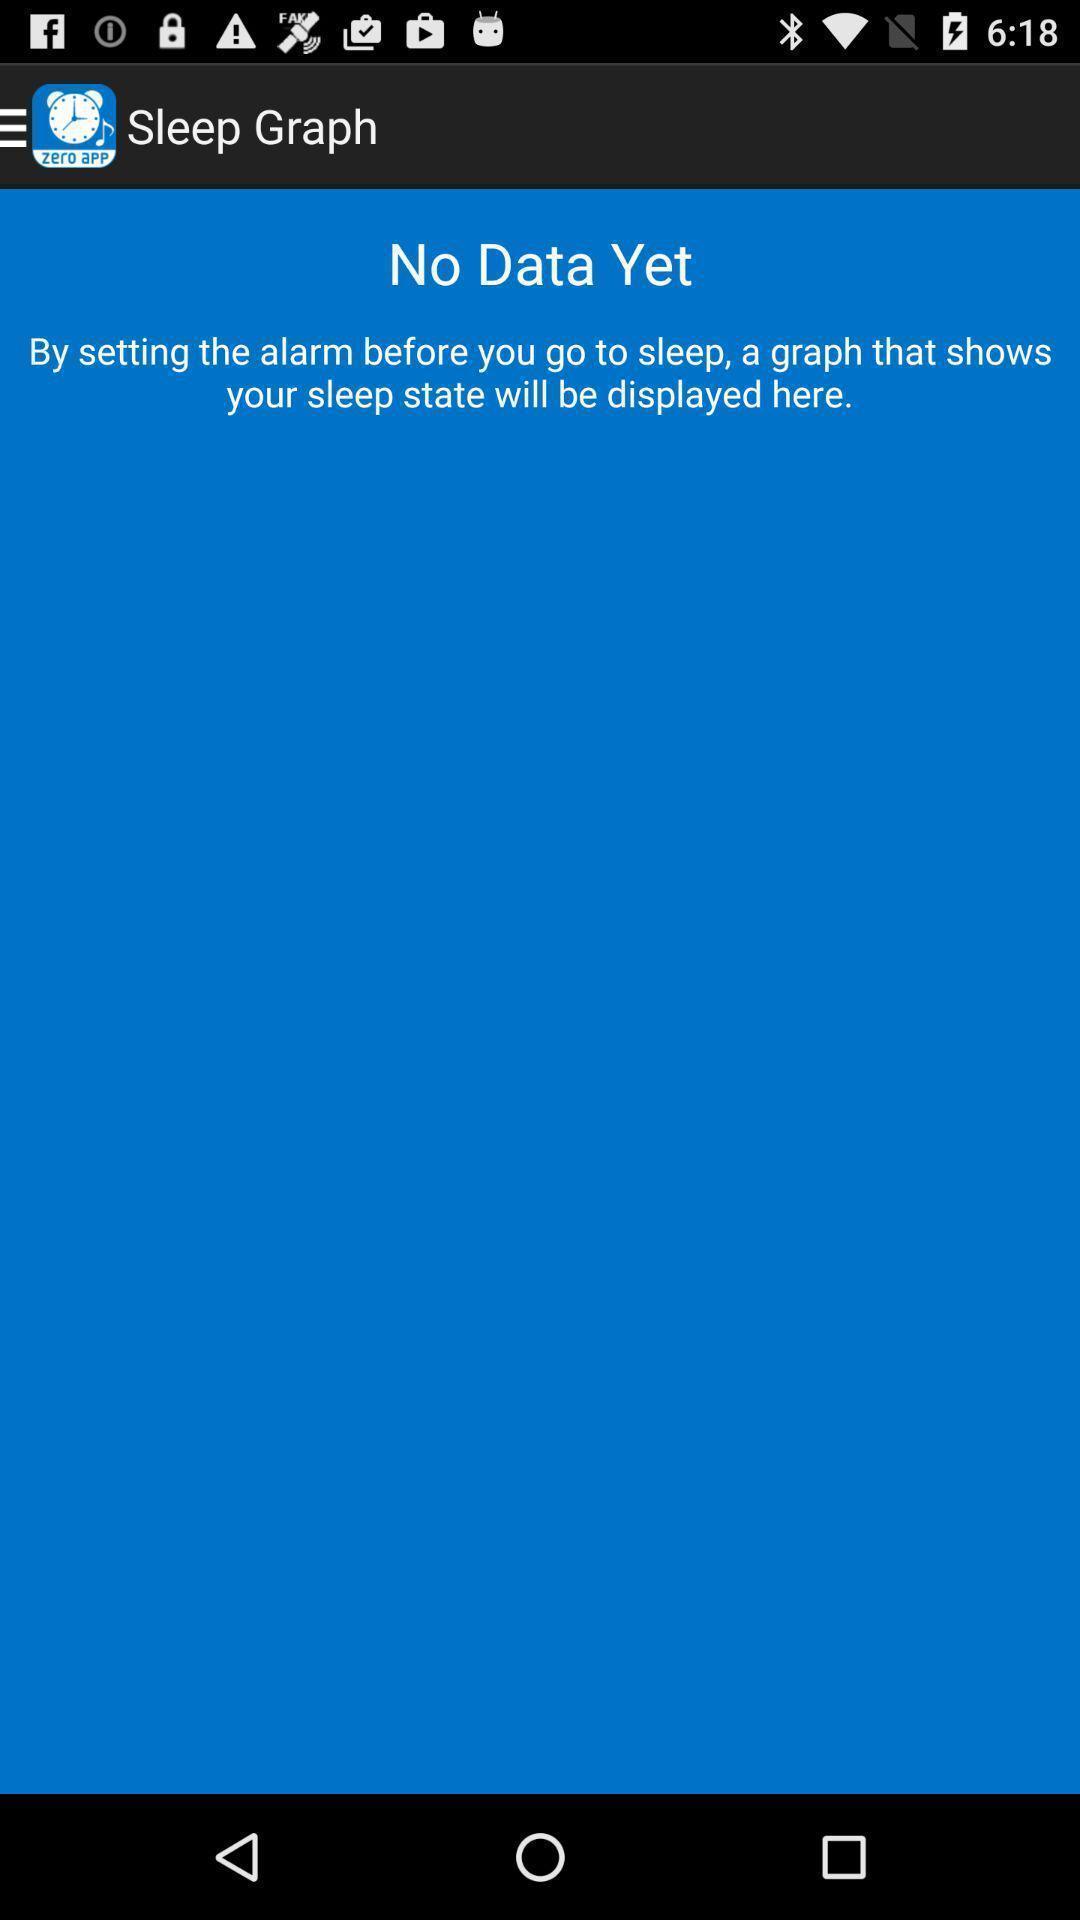Provide a detailed account of this screenshot. Page for showing the graph for the sleep state. 